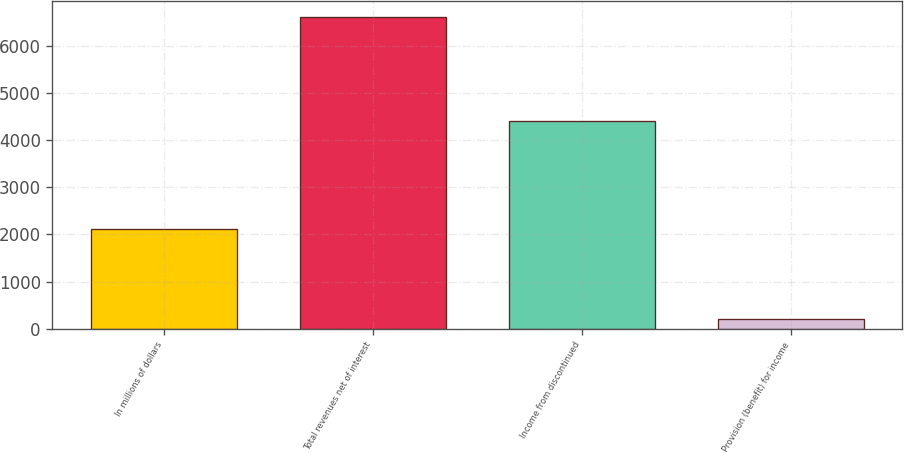<chart> <loc_0><loc_0><loc_500><loc_500><bar_chart><fcel>In millions of dollars<fcel>Total revenues net of interest<fcel>Income from discontinued<fcel>Provision (benefit) for income<nl><fcel>2118.9<fcel>6616<fcel>4410<fcel>207<nl></chart> 